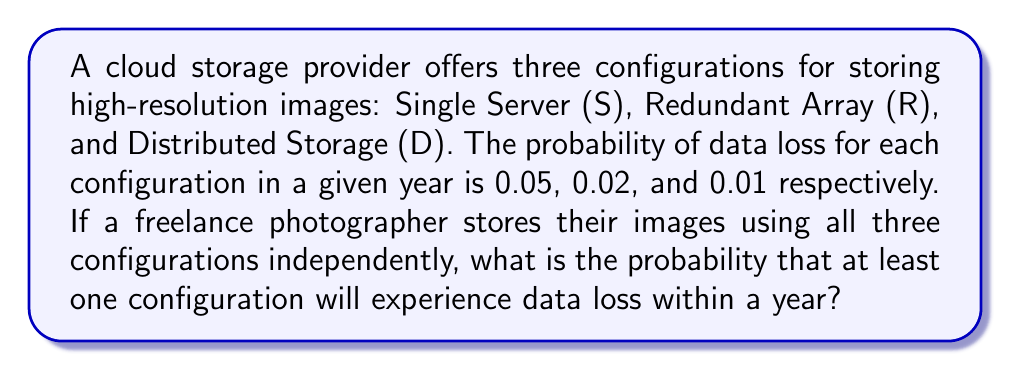Can you answer this question? Let's approach this step-by-step:

1) First, we need to find the probability that each configuration does not experience data loss:
   
   P(No loss in S) = 1 - 0.05 = 0.95
   P(No loss in R) = 1 - 0.02 = 0.98
   P(No loss in D) = 1 - 0.01 = 0.99

2) The probability that all configurations do not experience data loss is the product of these probabilities, as the events are independent:

   P(No loss in any) = P(No loss in S) × P(No loss in R) × P(No loss in D)
                     = 0.95 × 0.98 × 0.99
                     = 0.92169

3) Therefore, the probability that at least one configuration experiences data loss is the complement of this probability:

   P(At least one experiences loss) = 1 - P(No loss in any)
                                    = 1 - 0.92169
                                    = 0.07831

4) We can express this as a percentage:

   0.07831 × 100% ≈ 7.83%
Answer: $$0.07831$$ or $$7.83\%$$ 